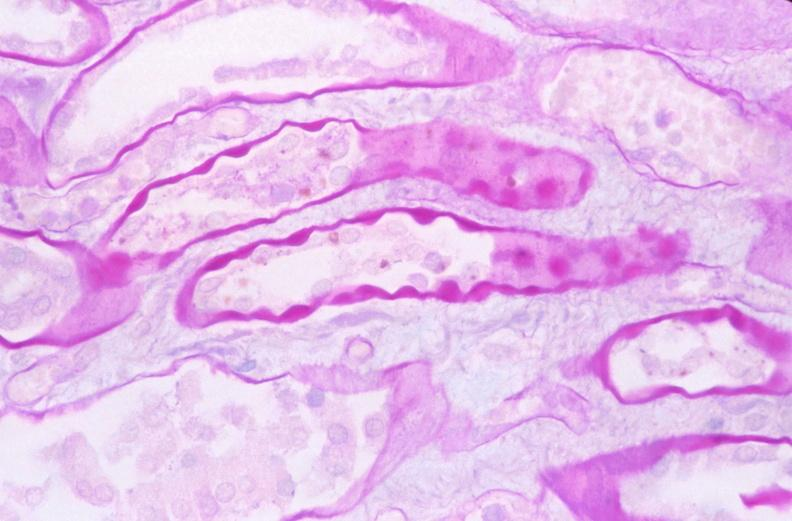where is this?
Answer the question using a single word or phrase. Urinary 